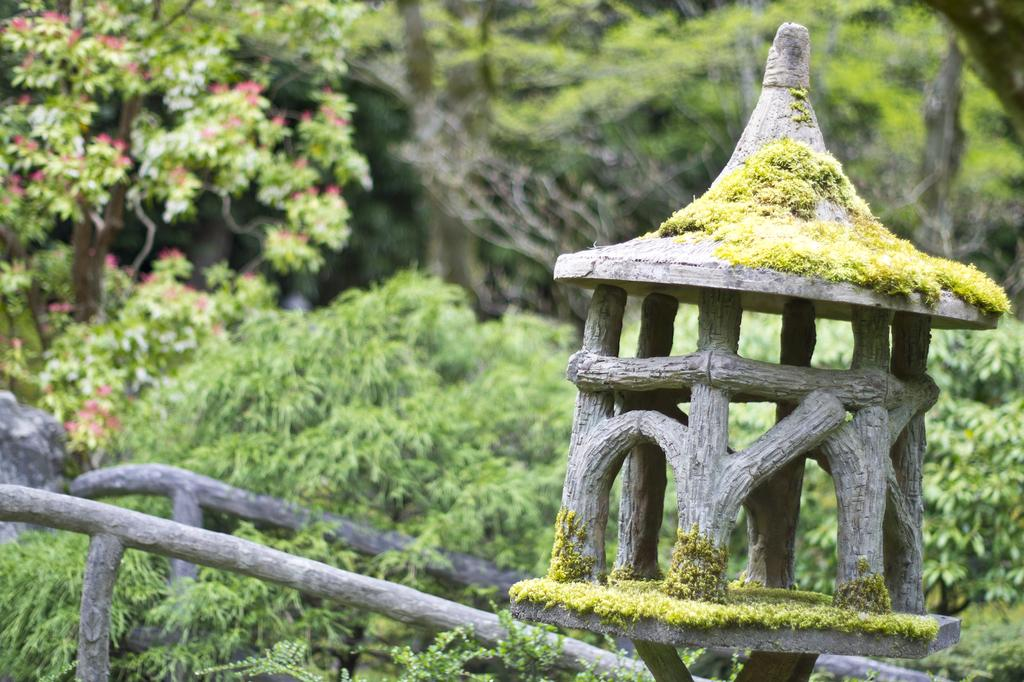What is the main structure in the image? There is a small house made with wooden blocks in the image. What type of natural elements can be seen in the image? There are plants and trees in the image. How would you describe the background of the image? The background of the image is slightly blurred. Can you see a trail leading to the lake in the image? There is no trail or lake present in the image; it features a small house made with wooden blocks, plants, trees, and a slightly blurred background. 